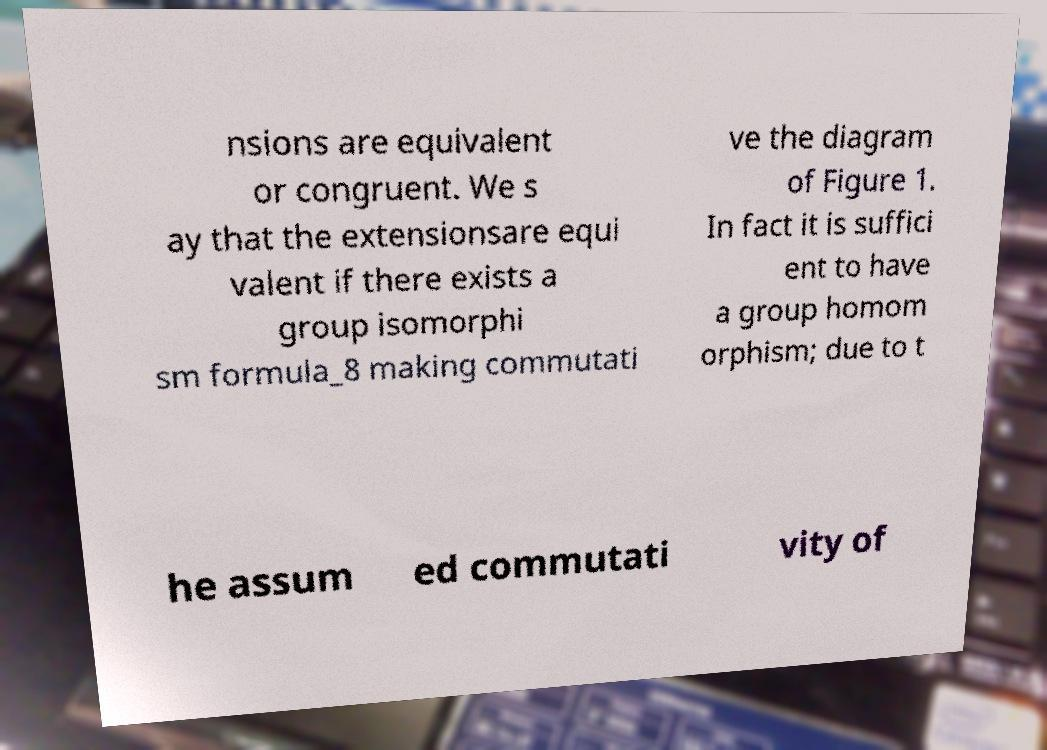Could you extract and type out the text from this image? nsions are equivalent or congruent. We s ay that the extensionsare equi valent if there exists a group isomorphi sm formula_8 making commutati ve the diagram of Figure 1. In fact it is suffici ent to have a group homom orphism; due to t he assum ed commutati vity of 